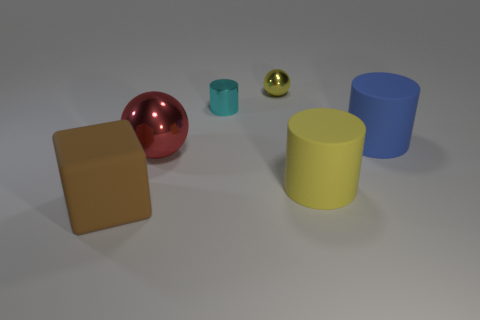Is the large cylinder in front of the large red metal sphere made of the same material as the big ball to the left of the tiny cyan cylinder?
Your answer should be very brief. No. What is the color of the big object that is both in front of the large shiny sphere and behind the brown object?
Make the answer very short. Yellow. There is a shiny thing that is in front of the shiny cylinder; how big is it?
Your response must be concise. Large. How many big brown objects have the same material as the brown cube?
Your answer should be compact. 0. There is a large rubber thing that is the same color as the small metal ball; what is its shape?
Provide a succinct answer. Cylinder. There is a metal object behind the tiny cyan thing; is its shape the same as the red thing?
Your answer should be compact. Yes. What is the color of the tiny object that is made of the same material as the small cylinder?
Offer a terse response. Yellow. There is a rubber thing behind the metal object that is to the left of the cyan thing; are there any yellow matte objects to the left of it?
Keep it short and to the point. Yes. The blue object is what shape?
Provide a succinct answer. Cylinder. Are there fewer big cylinders that are right of the yellow rubber object than small yellow spheres?
Keep it short and to the point. No. 